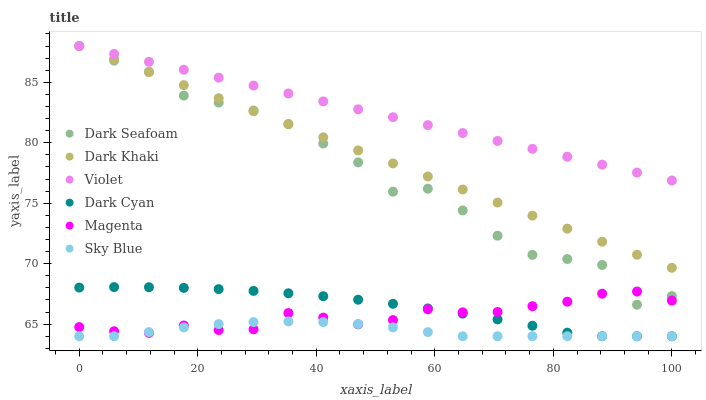Does Sky Blue have the minimum area under the curve?
Answer yes or no. Yes. Does Violet have the maximum area under the curve?
Answer yes or no. Yes. Does Dark Seafoam have the minimum area under the curve?
Answer yes or no. No. Does Dark Seafoam have the maximum area under the curve?
Answer yes or no. No. Is Violet the smoothest?
Answer yes or no. Yes. Is Dark Seafoam the roughest?
Answer yes or no. Yes. Is Dark Seafoam the smoothest?
Answer yes or no. No. Is Violet the roughest?
Answer yes or no. No. Does Dark Cyan have the lowest value?
Answer yes or no. Yes. Does Dark Seafoam have the lowest value?
Answer yes or no. No. Does Violet have the highest value?
Answer yes or no. Yes. Does Dark Cyan have the highest value?
Answer yes or no. No. Is Magenta less than Dark Khaki?
Answer yes or no. Yes. Is Violet greater than Magenta?
Answer yes or no. Yes. Does Violet intersect Dark Khaki?
Answer yes or no. Yes. Is Violet less than Dark Khaki?
Answer yes or no. No. Is Violet greater than Dark Khaki?
Answer yes or no. No. Does Magenta intersect Dark Khaki?
Answer yes or no. No. 